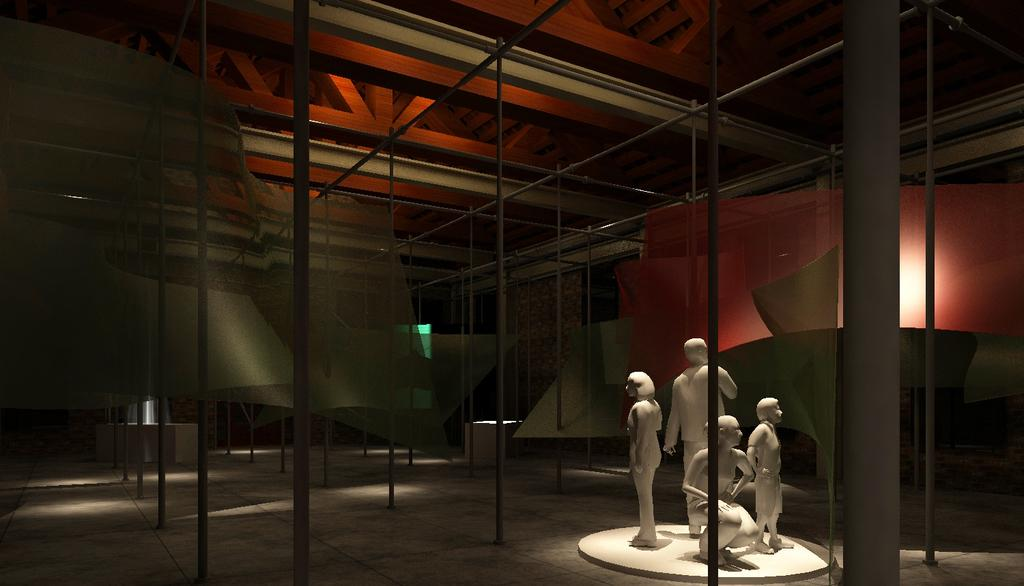What color are the statues in the image? The statues in the image are white. What else can be seen in the image besides the statues? There are poles and a wall in the image. Are there any objects on the floor in the image? Yes, there are other objects on the floor in the image. What type of eggs are being sold at the produce stand in the image? There is no produce stand or eggs present in the image. 